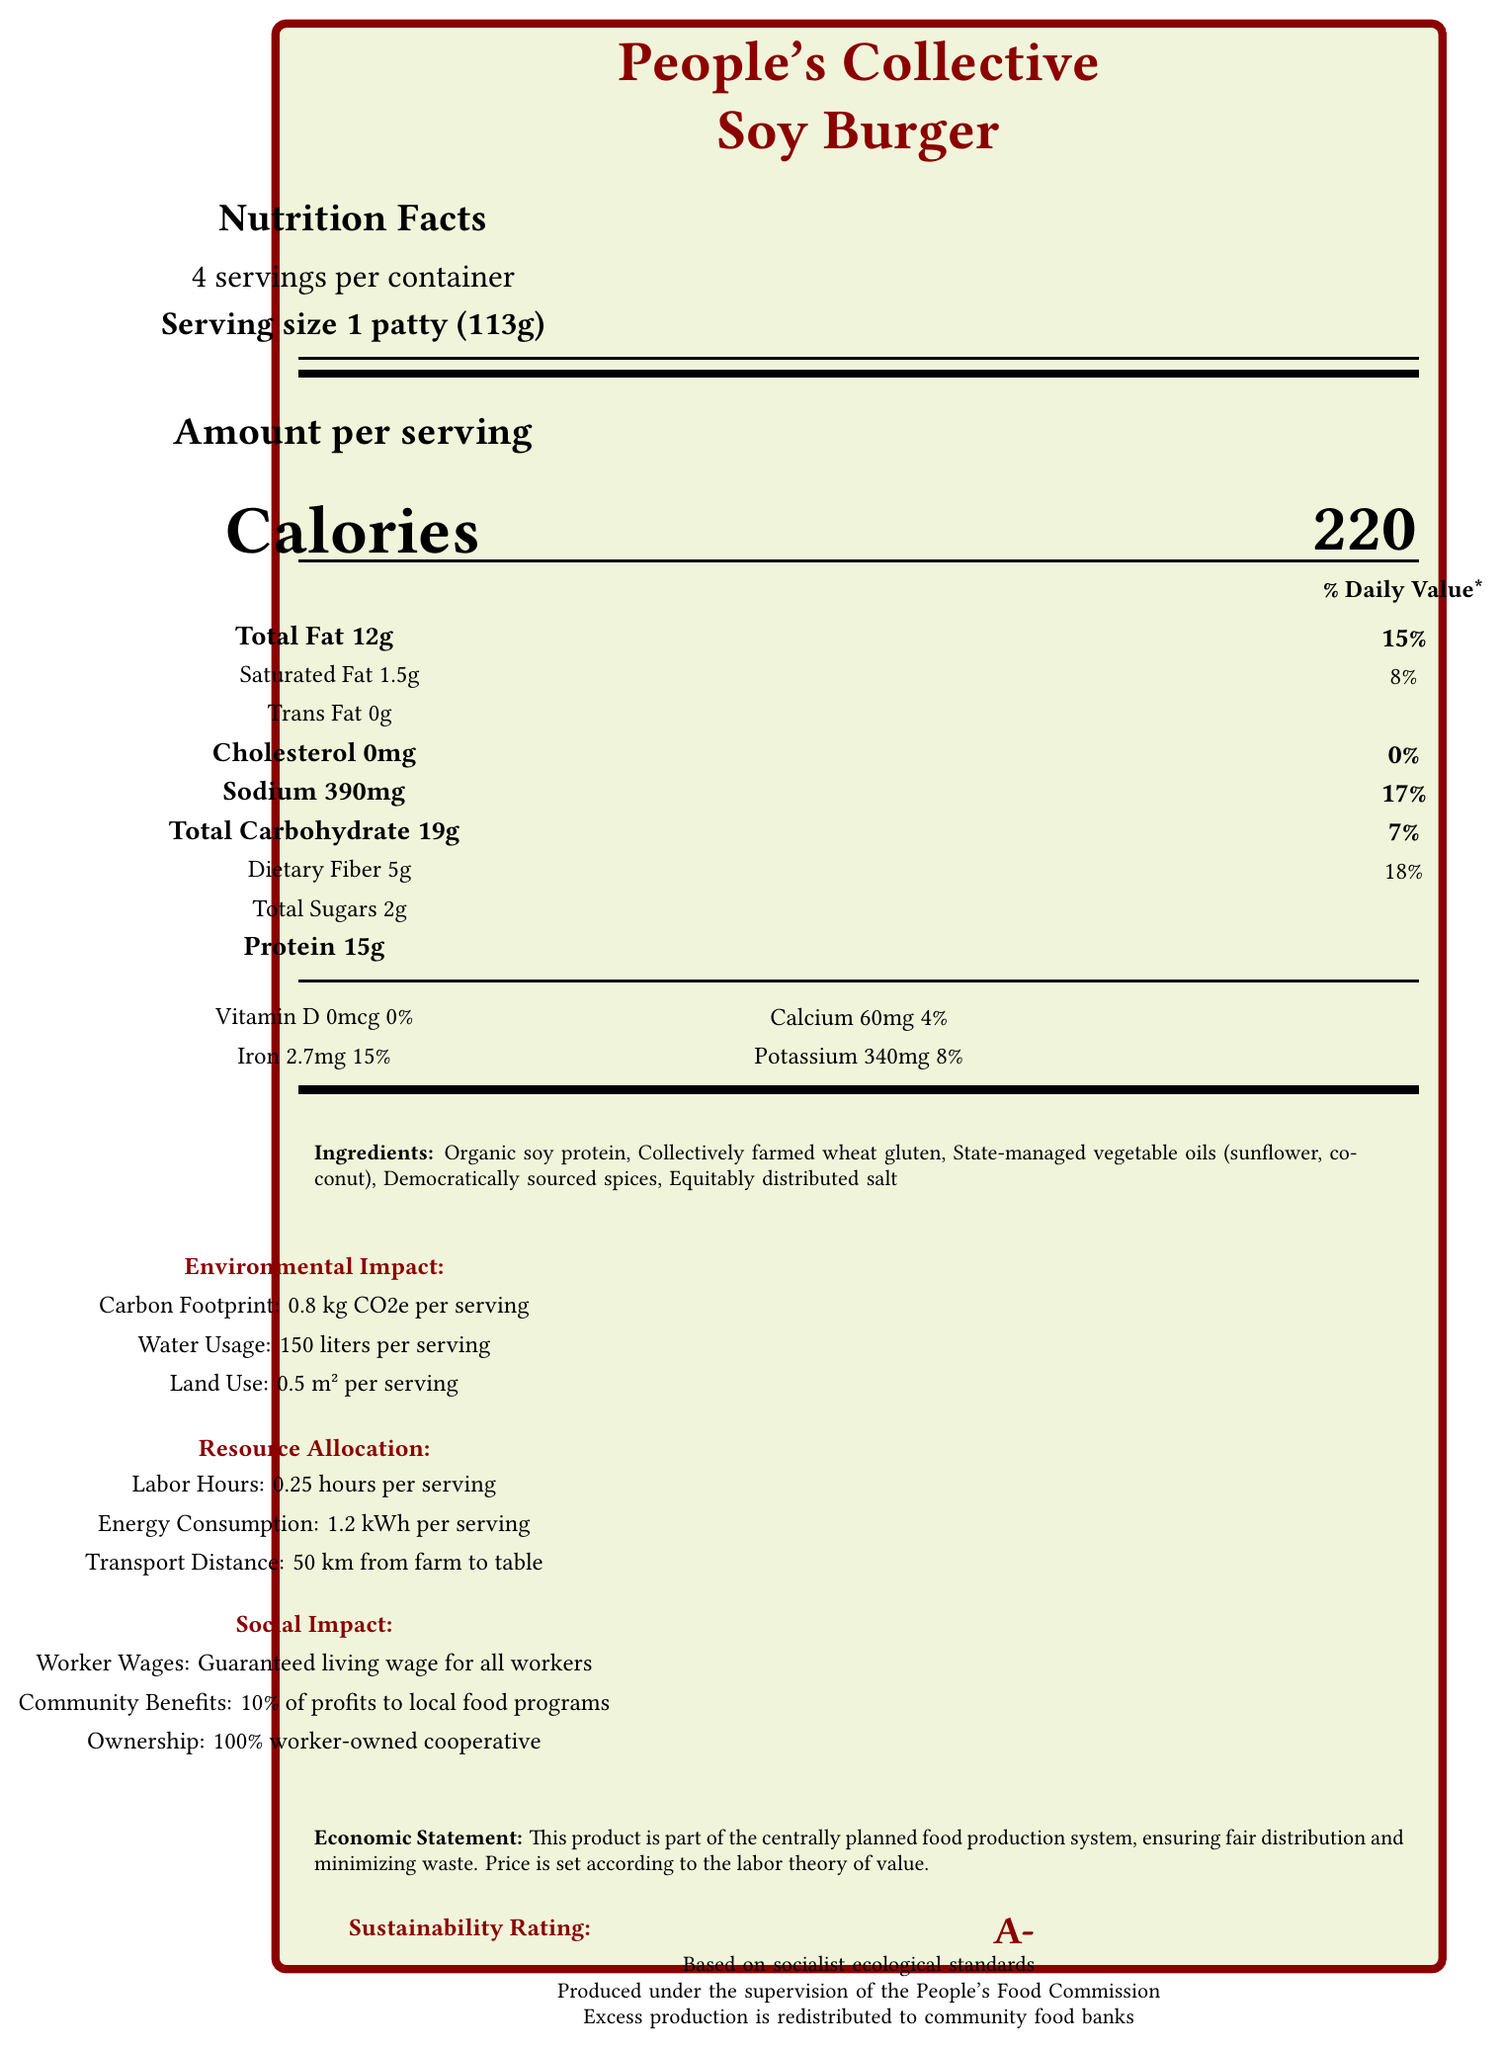what is the serving size of the People's Collective Soy Burger? The document explicitly lists the serving size as "1 patty (113g)".
Answer: 1 patty (113g) how many calories are there per serving? The document states that there are 220 calories per serving.
Answer: 220 how much iron does each serving contain? The document indicates that each serving contains 2.7mg of iron.
Answer: 2.7mg what is the sodium content per serving in percent daily value? The document shows that the sodium content per serving is 390mg, which represents 17% of the daily value.
Answer: 17% what type of ownership does the People's Collective Soy Burger cooperative have? The document specifies that the cooperative is 100% worker-owned.
Answer: 100% worker-owned cooperative which of the following ingredients is NOT listed in the People's Collective Soy Burger? A. Organic soy protein B. Collectively farmed wheat gluten C. State-managed vegetable oils D. Organic meat The document lists all ingredients, and Organic meat is not one of them.
Answer: D what is the environmental impact per serving regarding carbon footprint? A. 0.5 kg CO2e B. 0.8 kg CO2e C. 1.0 kg CO2e D. 1.2 kg CO2e The document indicates an environmental impact of 0.8 kg CO2e per serving.
Answer: B is the product produced under government oversight? The document states that it is produced under the supervision of the People's Food Commission.
Answer: Yes describe the main idea of the document The document includes detailed metrics on calories, fats, proteins, vitamins, and minerals, along with environmental metrics such as carbon footprint, water usage, and social metrics such as worker wages and community benefits, all under the governance of the People's Food Commission.
Answer: The document provides detailed nutritional facts, environmental impact, resource allocation, and social impact information about the People's Collective Soy Burger, emphasizing its sustainability, fair distribution, and cooperative ownership under a centrally planned food production system. what is the transport distance from farm to table for the product? The document specifies that the transport distance from farm to table is 50 km.
Answer: 50 km what percentage of profits is allocated to local food security programs? The document mentions that 10% of profits are allocated to local food security programs.
Answer: 10% how much total fat is in each serving of the People's Collective Soy Burger? The document lists the total fat content per serving as 12g.
Answer: 12g based on the document, what is the sustainability rating of the product? The document mentions that the sustainability rating is A-, based on socialist ecological standards.
Answer: A- what is the price of the People's Collective Soy Burger? The document does not provide any specific information about the price of the product.
Answer: Not enough information how many servings are there in one container of the People's Collective Soy Burger? The document states that there are 4 servings per container.
Answer: 4 